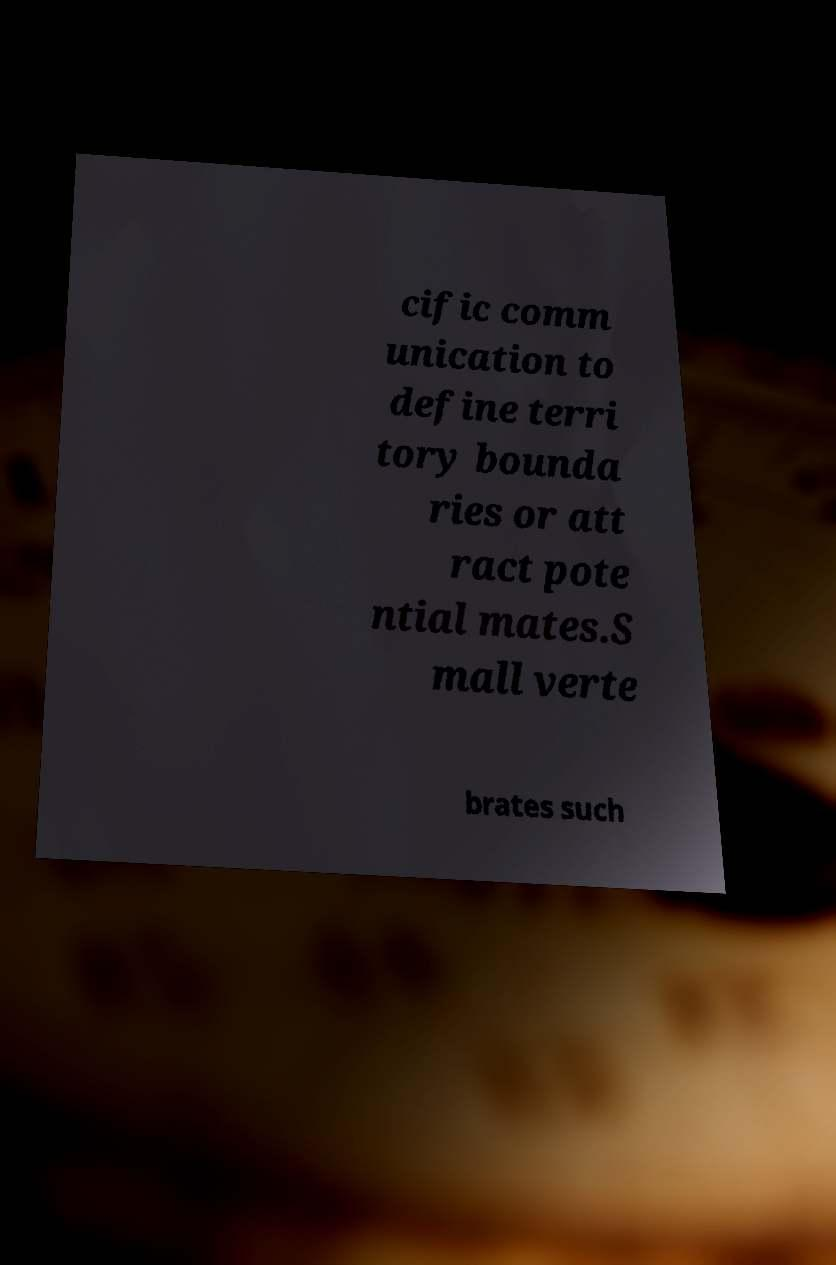There's text embedded in this image that I need extracted. Can you transcribe it verbatim? cific comm unication to define terri tory bounda ries or att ract pote ntial mates.S mall verte brates such 